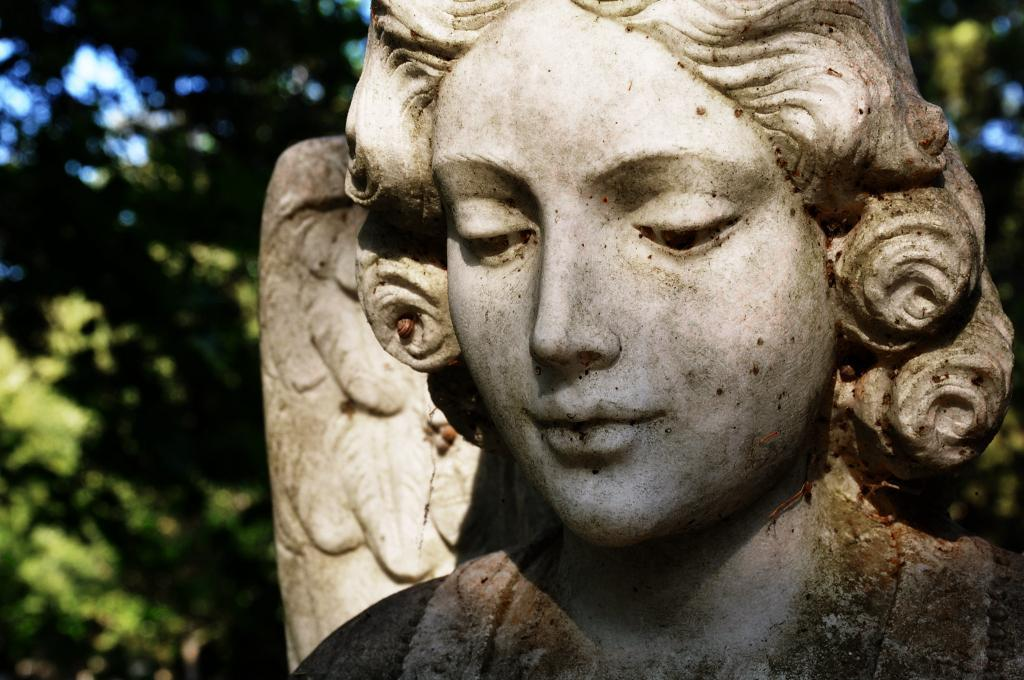What is the main subject of the image? There is a statue of a woman in the image. Can you describe the background of the image? The background of the image is blurry and green. How many attempts did the statue make to jump over the fence in the image? There is no fence present in the image, and the statue is not capable of making attempts to jump over anything. 